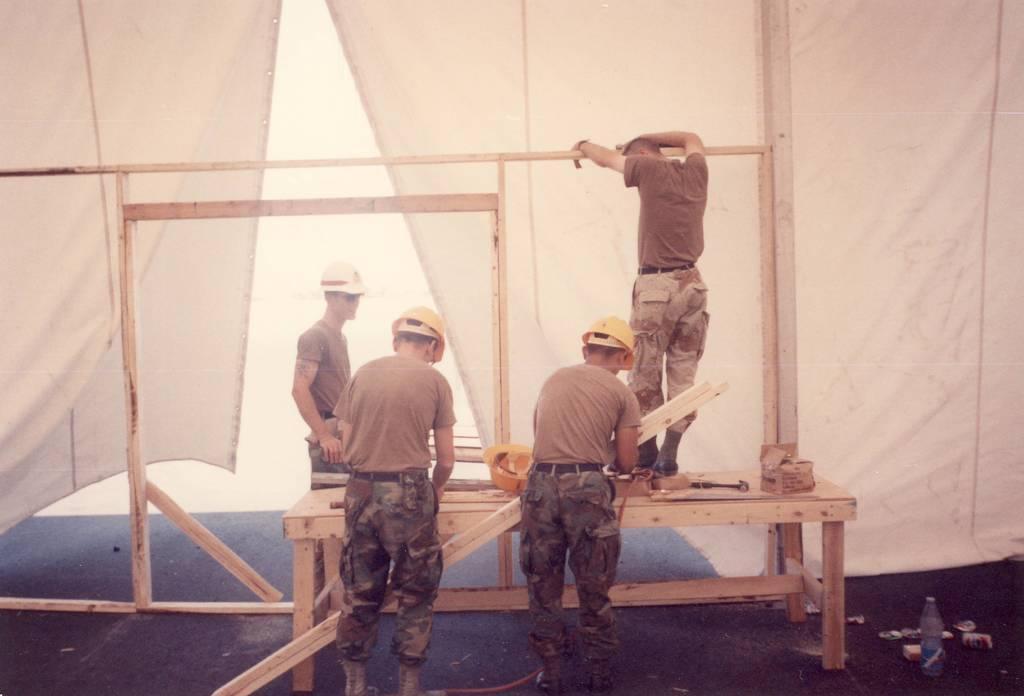Could you give a brief overview of what you see in this image? In the image we can see there are four men standing, wearing clothes, boots and three of them are wearing a helmet. Here we can see wooden table and on it there is a box. Here we can see white cloth, water bottle, can and the floor. 